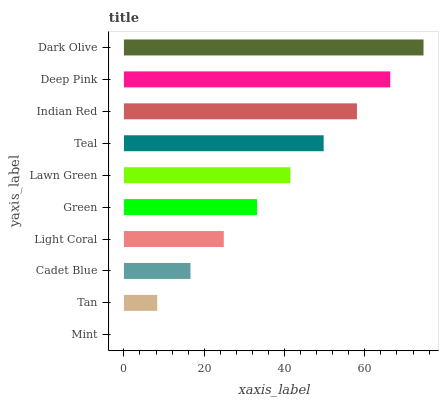Is Mint the minimum?
Answer yes or no. Yes. Is Dark Olive the maximum?
Answer yes or no. Yes. Is Tan the minimum?
Answer yes or no. No. Is Tan the maximum?
Answer yes or no. No. Is Tan greater than Mint?
Answer yes or no. Yes. Is Mint less than Tan?
Answer yes or no. Yes. Is Mint greater than Tan?
Answer yes or no. No. Is Tan less than Mint?
Answer yes or no. No. Is Lawn Green the high median?
Answer yes or no. Yes. Is Green the low median?
Answer yes or no. Yes. Is Light Coral the high median?
Answer yes or no. No. Is Lawn Green the low median?
Answer yes or no. No. 